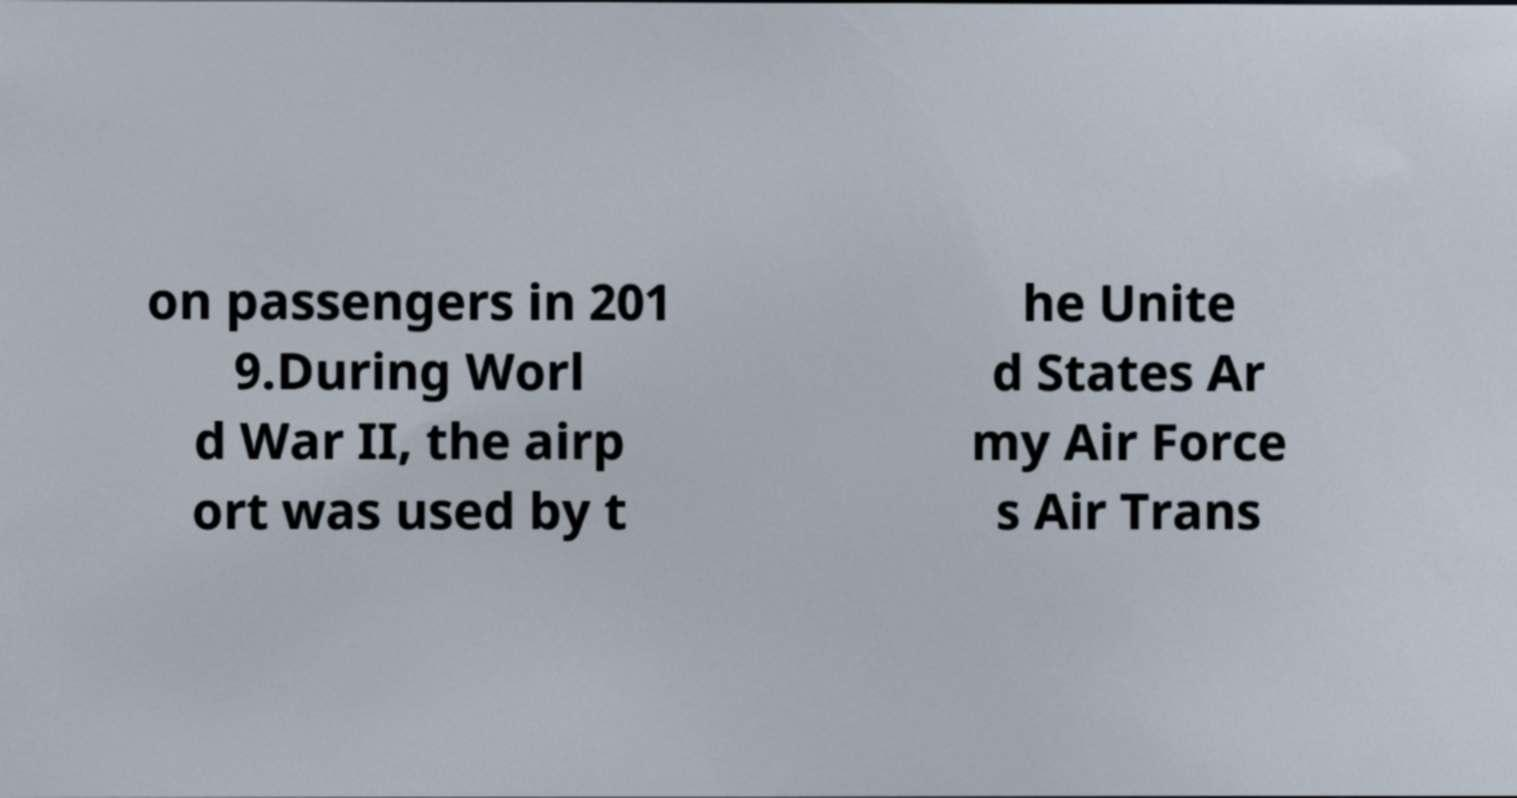Could you assist in decoding the text presented in this image and type it out clearly? on passengers in 201 9.During Worl d War II, the airp ort was used by t he Unite d States Ar my Air Force s Air Trans 